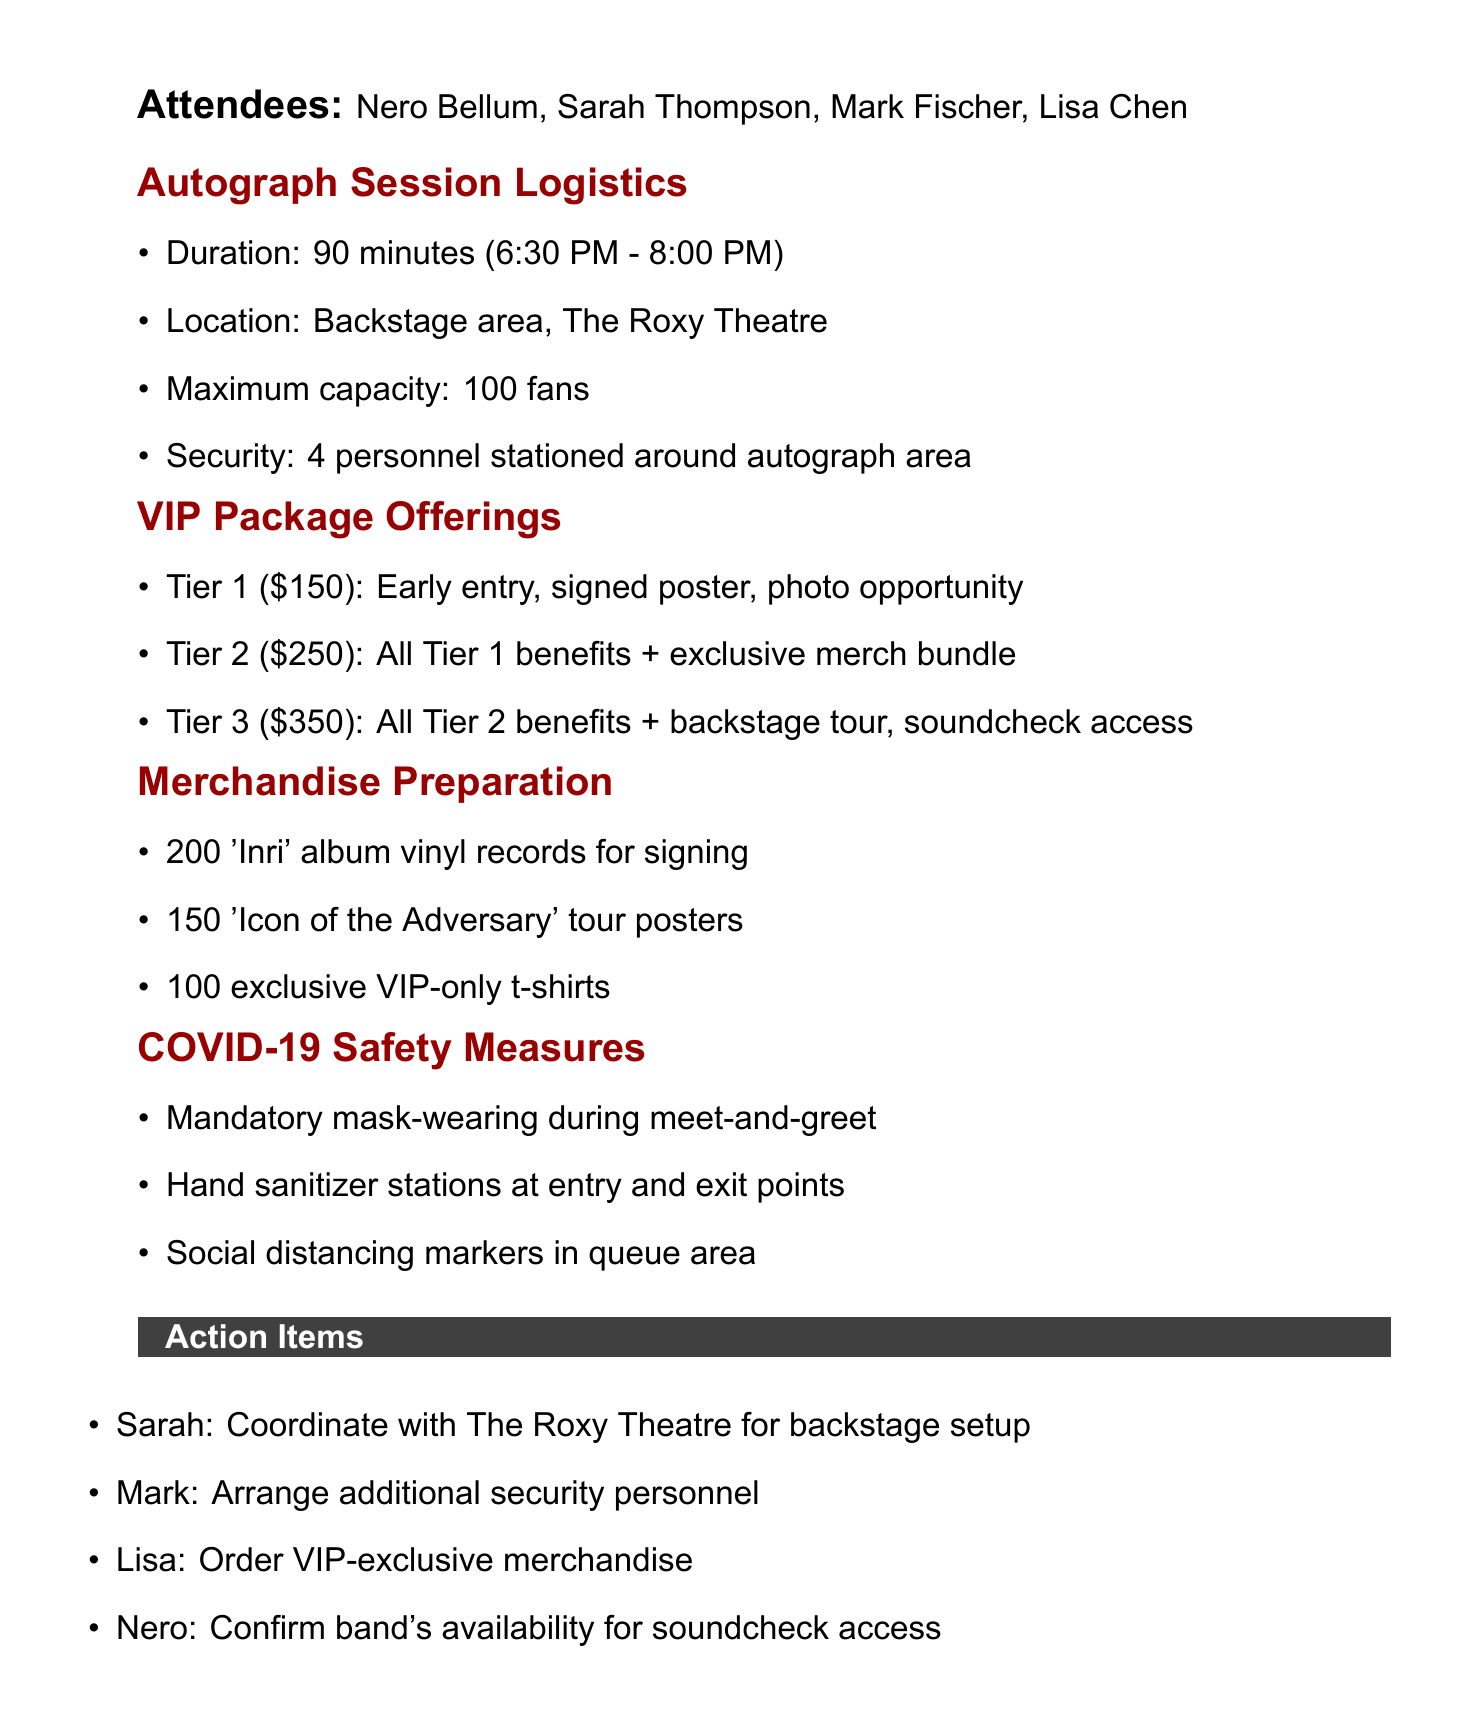What is the date of the meeting? The date of the meeting is mentioned at the beginning of the document.
Answer: September 15, 2023 What is the maximum capacity for the autograph session? The maximum capacity is specified under the Autograph Session Logistics section.
Answer: 100 fans How long will the autograph session last? The duration of the autograph session is detailed in the Autograph Session Logistics section.
Answer: 90 minutes What are the benefits of Tier 2 VIP package? The benefits of Tier 2 are listed under VIP Package Offerings and include access to Tier 1 benefits plus additional items.
Answer: All Tier 1 benefits, plus exclusive merch bundle How many 'Inri' album vinyl records are prepared for signing? The number of vinyl records is mentioned in the Merchandise Preparation section.
Answer: 200 What safety measure is required during the meet-and-greet? The document lists COVID-19 safety measures, one of which requires a specific behavior during the event.
Answer: Mandatory mask-wearing Who is responsible for coordinating with the venue? The action items outline responsibilities, including who will handle the venue coordination.
Answer: Sarah What tier includes a backstage tour? The information regarding tiers and their offerings allows us to determine which tier includes this benefit.
Answer: Tier 3 